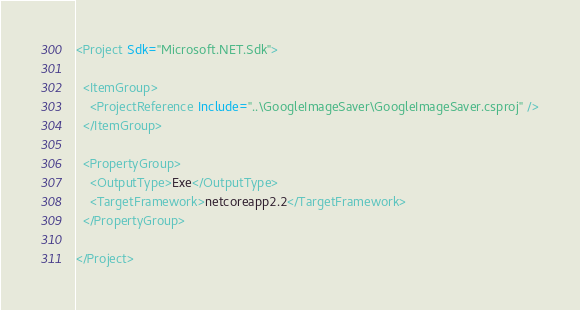<code> <loc_0><loc_0><loc_500><loc_500><_XML_><Project Sdk="Microsoft.NET.Sdk">

  <ItemGroup>
    <ProjectReference Include="..\GoogleImageSaver\GoogleImageSaver.csproj" />
  </ItemGroup>

  <PropertyGroup>
    <OutputType>Exe</OutputType>
    <TargetFramework>netcoreapp2.2</TargetFramework>
  </PropertyGroup>

</Project>
</code> 